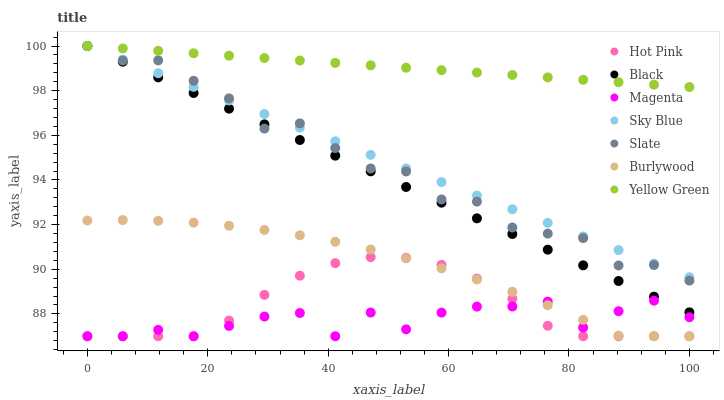Does Magenta have the minimum area under the curve?
Answer yes or no. Yes. Does Yellow Green have the maximum area under the curve?
Answer yes or no. Yes. Does Burlywood have the minimum area under the curve?
Answer yes or no. No. Does Burlywood have the maximum area under the curve?
Answer yes or no. No. Is Yellow Green the smoothest?
Answer yes or no. Yes. Is Magenta the roughest?
Answer yes or no. Yes. Is Burlywood the smoothest?
Answer yes or no. No. Is Burlywood the roughest?
Answer yes or no. No. Does Burlywood have the lowest value?
Answer yes or no. Yes. Does Slate have the lowest value?
Answer yes or no. No. Does Sky Blue have the highest value?
Answer yes or no. Yes. Does Burlywood have the highest value?
Answer yes or no. No. Is Burlywood less than Slate?
Answer yes or no. Yes. Is Slate greater than Magenta?
Answer yes or no. Yes. Does Sky Blue intersect Yellow Green?
Answer yes or no. Yes. Is Sky Blue less than Yellow Green?
Answer yes or no. No. Is Sky Blue greater than Yellow Green?
Answer yes or no. No. Does Burlywood intersect Slate?
Answer yes or no. No. 